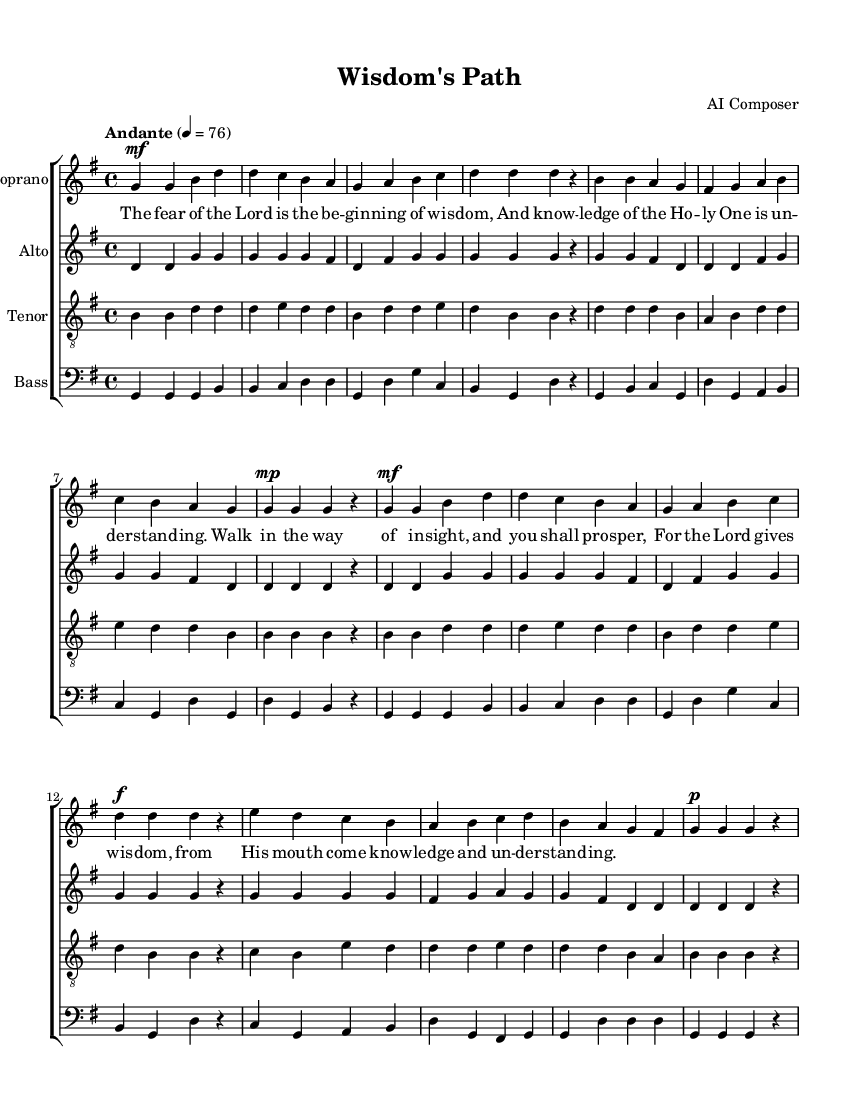What is the key signature of this music? The key signature is indicated at the beginning of the staff, showing one sharp, which corresponds to the key of G major.
Answer: G major What is the time signature of this composition? The time signature is found at the beginning of the score, indicated as a fraction, showing 4 beats per measure.
Answer: 4/4 What is the tempo marking for this piece? The tempo marking is located at the beginning of the score and indicates how fast the piece should be played, which is "Andante" at a metronome marking of 76 beats per minute.
Answer: Andante What is the text of the lyrics? The lyrics are placed under the soprano staff and provide the text that corresponds to the melody, explicitly focused on wisdom and the fear of the Lord.
Answer: The fear of the Lord is the beginning of wisdom, and knowledge of the Holy One is understanding How many voices are written in this arrangement? The score clearly displays four staves, each representing a different vocal part: Soprano, Alto, Tenor, and Bass, indicating four distinct voices in this choral composition.
Answer: Four Which biblical theme is emphasized in the lyrics? The lyrics reference wisdom and guidance from the Lord, focusing on the concept that fear of the Lord is the beginning of wisdom, directing attention to biblical teachings.
Answer: Wisdom and fear of the Lord Which voice part has the melody? The melody is typically sung by the soprano voice, which presents the main theme and is usually the highest part in choral compositions.
Answer: Soprano 